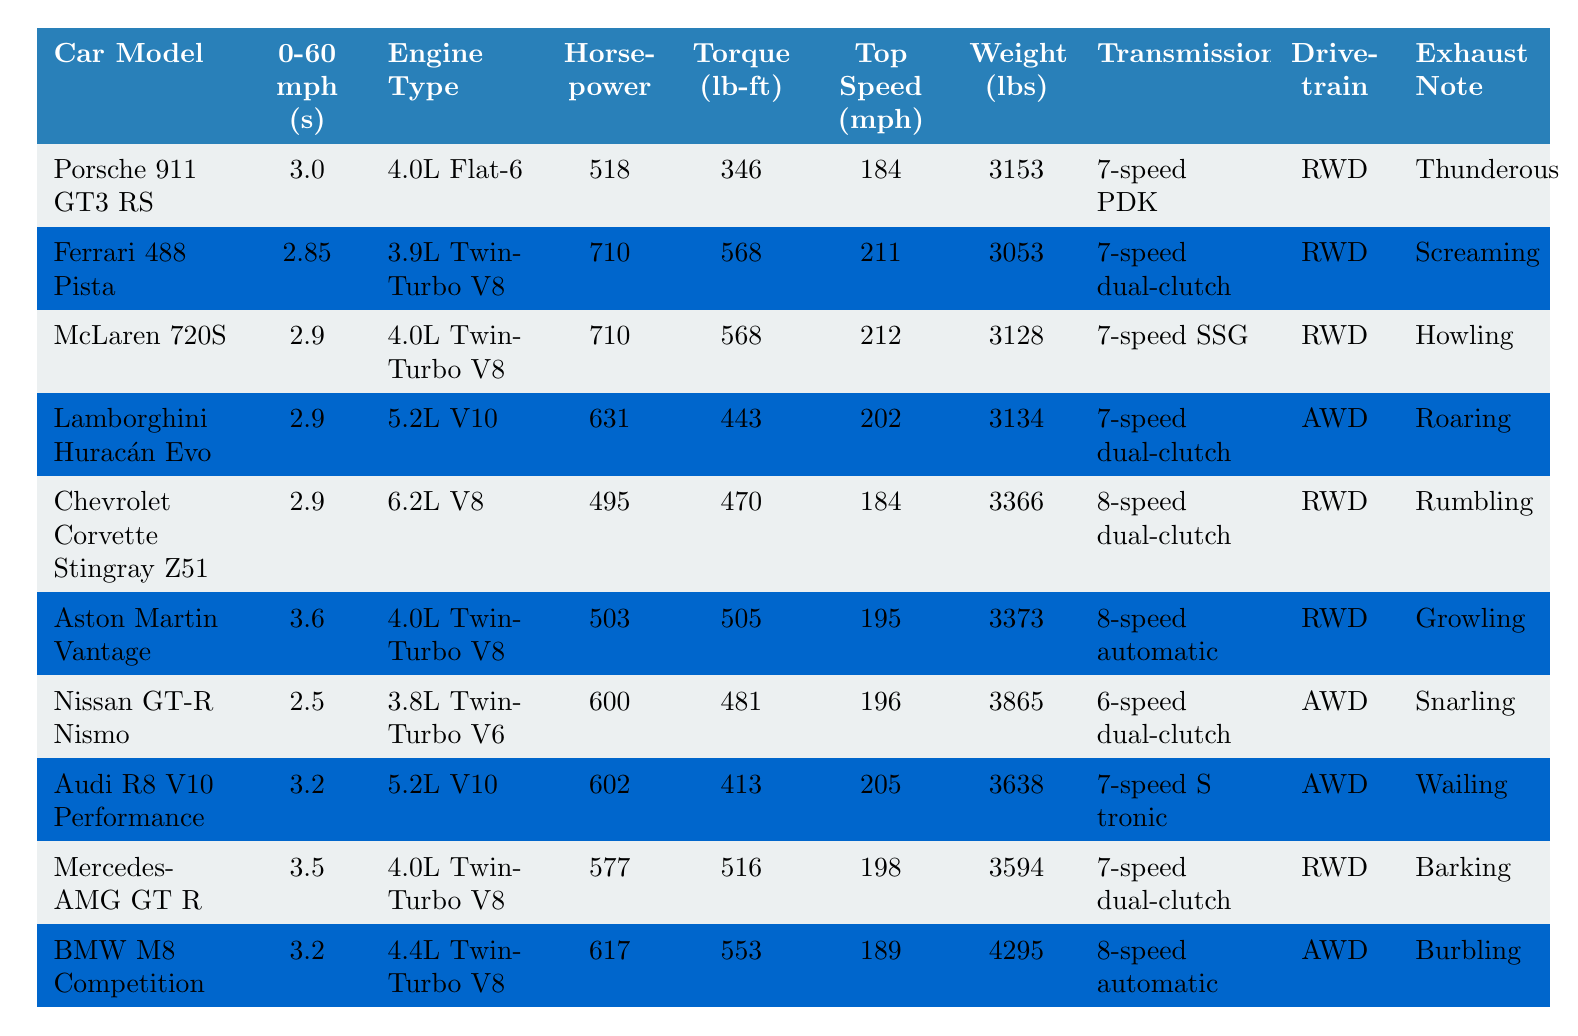What is the fastest car in terms of 0-60 mph time? The fastest car can be identified by looking for the lowest value in the "0-60 mph (s)" column. The Porsche 911 GT3 RS has a time of 3.0 seconds, which is the smallest among all cars listed.
Answer: Porsche 911 GT3 RS Which car has the most horsepower? To find the car with the most horsepower, we need to examine the "Horsepower" column and locate the highest value. The Ferrari 488 Pista has 710 horsepower, which is the greatest in the table.
Answer: Ferrari 488 Pista Is the Nissan GT-R Nismo faster than the Chevrolet Corvette Stingray Z51 in 0-60 mph time? Comparing the "0-60 mph (s)" values for Nissan GT-R Nismo (2.5 seconds) and Chevrolet Corvette Stingray Z51 (2.9 seconds), we see that 2.5 is less than 2.9, meaning the Nissan GT-R Nismo is faster.
Answer: Yes What is the average weight of the cars listed? First, we sum the weights of all cars: 3153 + 3053 + 3128 + 3134 + 3366 + 3373 + 3865 + 3638 + 3594 + 4295 = 34,740 lbs. There are 10 cars, so we divide 34,740 by 10 to get the average: 34,740 / 10 = 3,474 lbs.
Answer: 3474 lbs Which car has the highest torque and what is that torque value? We check the "Torque (lb-ft)" column to identify the highest value. The Ferrari 488 Pista has a torque of 568 lb-ft, which is the maximum in the table.
Answer: Ferrari 488 Pista, 568 lb-ft How many cars have a top speed greater than 200 mph? We analyze the "Top Speed (mph)" column and count cars with speeds exceeding 200 mph. The cars meeting this criterion are the Ferrari 488 Pista (211 mph), McLaren 720S (212 mph), Lamborghini Huracán Evo (202 mph), and Audi R8 V10 Performance (205 mph). This gives us a total of 4 cars.
Answer: 4 Is it true that all cars listed have a turbocharged engine? From the "Engine Type" column, the Ford V8s are not turbocharged (e.g., 4.0L Flat-6, 5.2L V10, etc.). Therefore, not all of them have a turbocharged engine.
Answer: No What is the difference in horsepower between the McLaren 720S and the Aston Martin Vantage? The McLaren 720S has 710 horsepower, while the Aston Martin Vantage has 503 horsepower. We find the difference by subtracting: 710 - 503 = 207 hp.
Answer: 207 hp Which car has the most unique exhaust note according to the table? By referring to the "Exhaust Note" column, we can determine unique sounds. Each car's description is subjective, but the Lamborghini Huracán Evo's "Roaring" is often considered very distinctive.
Answer: Lamborghini Huracán Evo Which drivetrain type is most common among the listed cars? We can tally the "Drivetrain" column. RWD appears for the Porsche 911 GT3 RS, Ferrari 488 Pista, McLaren 720S, Chevrolet Corvette Stingray Z51, Aston Martin Vantage, and Mercedes-AMG GT R, totaling 6 cars. AWD appears for Lamborghini Huracán Evo, Nissan GT-R Nismo, Audi R8 V10 Performance, and BMW M8 Competition, totaling 4 cars. RWD is more common.
Answer: RWD 